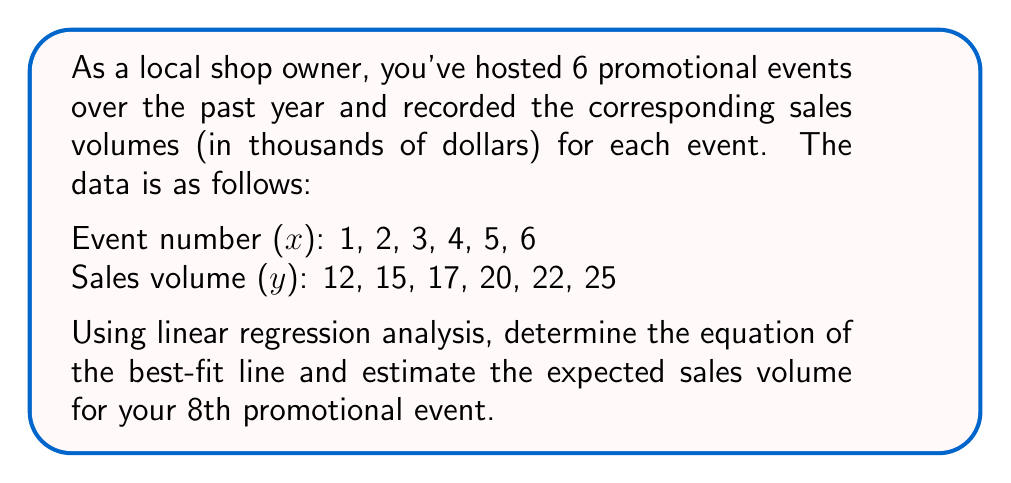Could you help me with this problem? To solve this problem, we'll use linear regression analysis to find the best-fit line equation and then use it to estimate the sales volume for the 8th event.

1. First, let's calculate the necessary sums:
   $n = 6$ (number of data points)
   $\sum x = 1 + 2 + 3 + 4 + 5 + 6 = 21$
   $\sum y = 12 + 15 + 17 + 20 + 22 + 25 = 111$
   $\sum xy = (1 \cdot 12) + (2 \cdot 15) + (3 \cdot 17) + (4 \cdot 20) + (5 \cdot 22) + (6 \cdot 25) = 455$
   $\sum x^2 = 1^2 + 2^2 + 3^2 + 4^2 + 5^2 + 6^2 = 91$

2. Calculate the slope (m) of the best-fit line:
   $$m = \frac{n\sum xy - \sum x \sum y}{n\sum x^2 - (\sum x)^2}$$
   $$m = \frac{6(455) - 21(111)}{6(91) - 21^2} = \frac{2730 - 2331}{546 - 441} = \frac{399}{105} = 3.8$$

3. Calculate the y-intercept (b) of the best-fit line:
   $$b = \frac{\sum y - m\sum x}{n}$$
   $$b = \frac{111 - 3.8(21)}{6} = \frac{111 - 79.8}{6} = \frac{31.2}{6} = 5.2$$

4. The equation of the best-fit line is:
   $$y = mx + b$$
   $$y = 3.8x + 5.2$$

5. To estimate the sales volume for the 8th event, substitute x = 8 into the equation:
   $$y = 3.8(8) + 5.2 = 30.4 + 5.2 = 35.6$$

Therefore, the estimated sales volume for the 8th promotional event is $35,600.
Answer: The equation of the best-fit line is $y = 3.8x + 5.2$, and the estimated sales volume for the 8th promotional event is $35,600. 